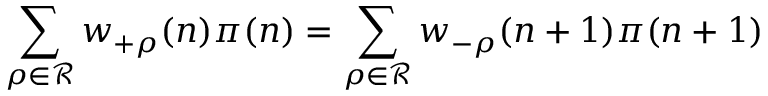Convert formula to latex. <formula><loc_0><loc_0><loc_500><loc_500>\sum _ { \rho \in { \mathcal { R } } } w _ { + \rho } ( n ) \pi ( n ) = \sum _ { \rho \in { \mathcal { R } } } w _ { - \rho } ( n + 1 ) \pi ( n + 1 )</formula> 